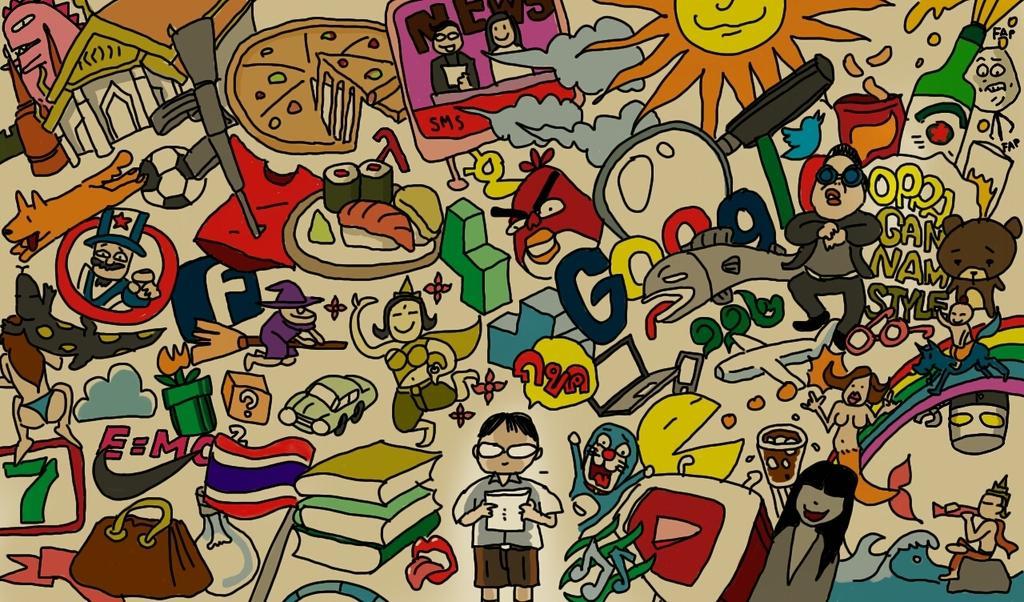Can you describe this image briefly? This is the poster image in which there are many cartoons and there is some text written on the image and there are books. 